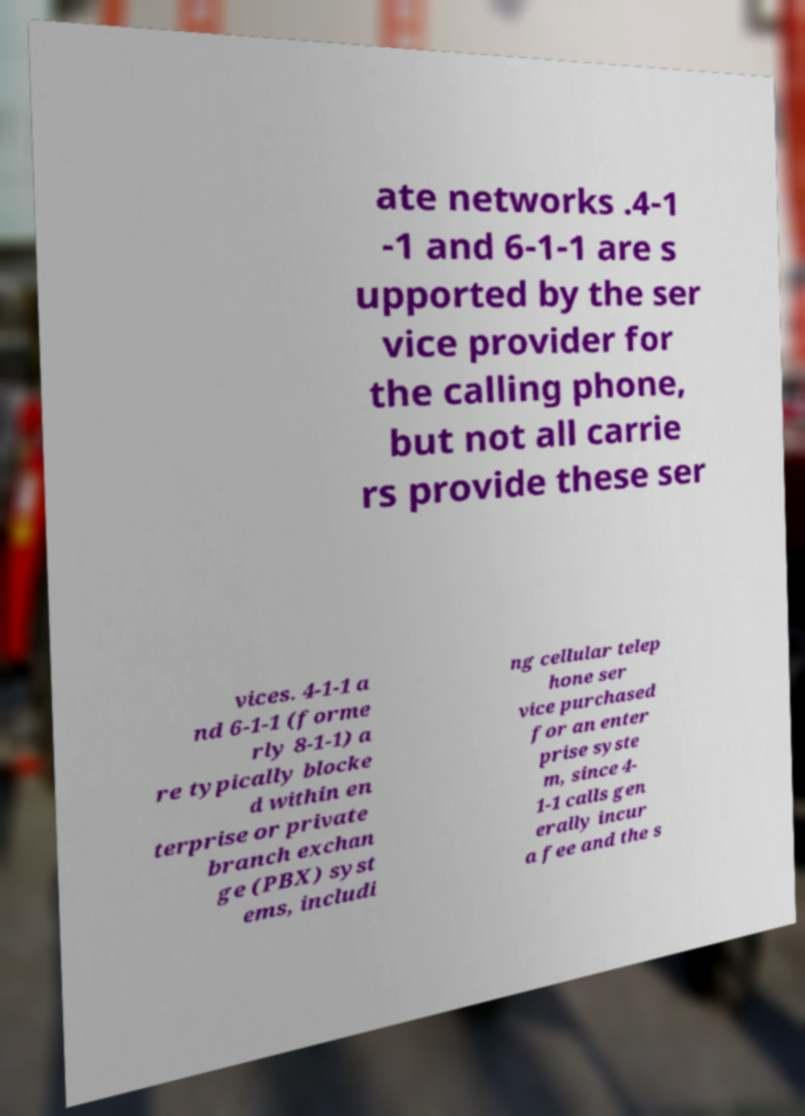Can you accurately transcribe the text from the provided image for me? ate networks .4-1 -1 and 6-1-1 are s upported by the ser vice provider for the calling phone, but not all carrie rs provide these ser vices. 4-1-1 a nd 6-1-1 (forme rly 8-1-1) a re typically blocke d within en terprise or private branch exchan ge (PBX) syst ems, includi ng cellular telep hone ser vice purchased for an enter prise syste m, since 4- 1-1 calls gen erally incur a fee and the s 